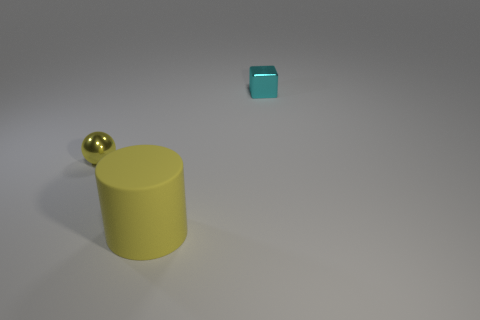Add 2 small cyan matte cylinders. How many objects exist? 5 Subtract all cubes. How many objects are left? 2 Add 1 small cubes. How many small cubes are left? 2 Add 3 tiny gray objects. How many tiny gray objects exist? 3 Subtract 0 red cubes. How many objects are left? 3 Subtract all shiny balls. Subtract all tiny yellow metallic objects. How many objects are left? 1 